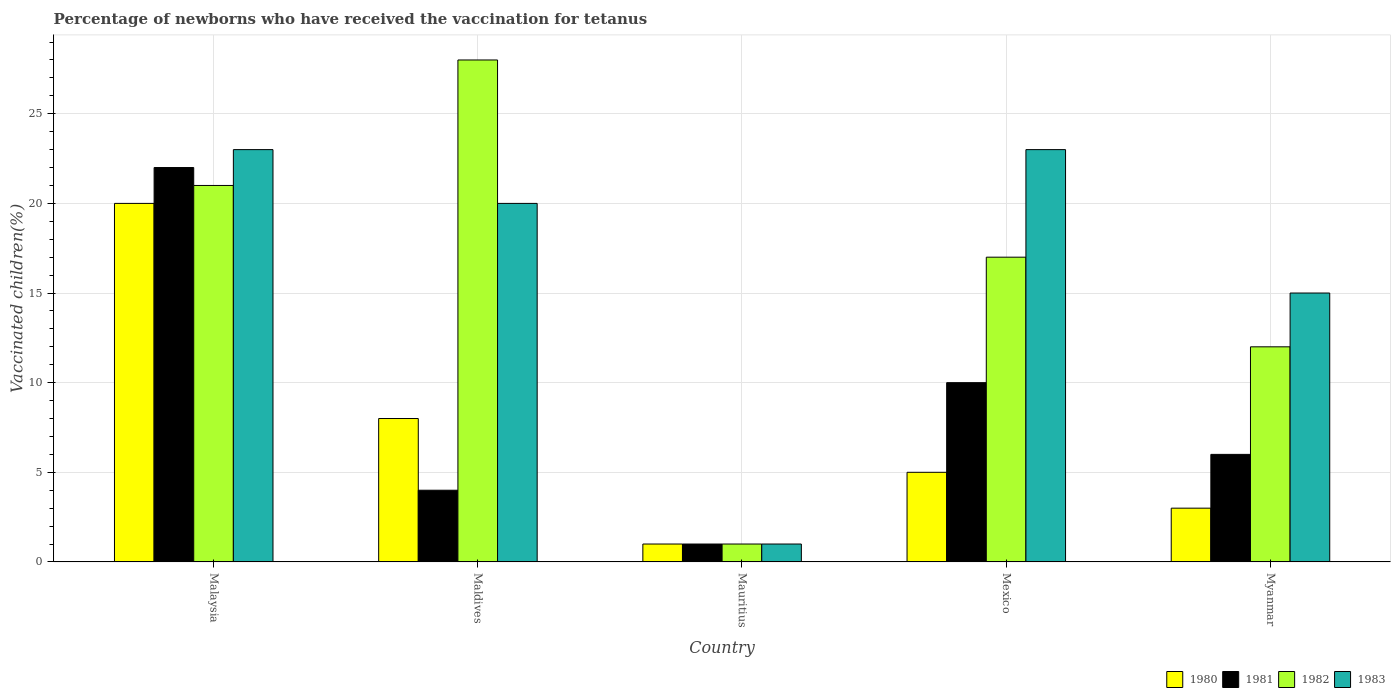How many groups of bars are there?
Your response must be concise. 5. Are the number of bars per tick equal to the number of legend labels?
Provide a succinct answer. Yes. Are the number of bars on each tick of the X-axis equal?
Give a very brief answer. Yes. In how many cases, is the number of bars for a given country not equal to the number of legend labels?
Your response must be concise. 0. What is the percentage of vaccinated children in 1983 in Malaysia?
Make the answer very short. 23. Across all countries, what is the maximum percentage of vaccinated children in 1982?
Make the answer very short. 28. Across all countries, what is the minimum percentage of vaccinated children in 1981?
Offer a terse response. 1. In which country was the percentage of vaccinated children in 1980 maximum?
Your answer should be compact. Malaysia. In which country was the percentage of vaccinated children in 1981 minimum?
Offer a very short reply. Mauritius. What is the ratio of the percentage of vaccinated children in 1981 in Maldives to that in Mexico?
Offer a very short reply. 0.4. Is the percentage of vaccinated children in 1980 in Malaysia less than that in Mauritius?
Ensure brevity in your answer.  No. What is the difference between the highest and the second highest percentage of vaccinated children in 1982?
Your response must be concise. -11. What does the 2nd bar from the left in Mexico represents?
Offer a terse response. 1981. What does the 2nd bar from the right in Malaysia represents?
Offer a very short reply. 1982. Is it the case that in every country, the sum of the percentage of vaccinated children in 1982 and percentage of vaccinated children in 1980 is greater than the percentage of vaccinated children in 1983?
Offer a very short reply. No. Does the graph contain any zero values?
Your answer should be compact. No. How are the legend labels stacked?
Provide a succinct answer. Horizontal. What is the title of the graph?
Give a very brief answer. Percentage of newborns who have received the vaccination for tetanus. What is the label or title of the Y-axis?
Your response must be concise. Vaccinated children(%). What is the Vaccinated children(%) of 1980 in Maldives?
Provide a short and direct response. 8. What is the Vaccinated children(%) in 1981 in Maldives?
Your answer should be very brief. 4. What is the Vaccinated children(%) in 1983 in Maldives?
Your response must be concise. 20. What is the Vaccinated children(%) in 1980 in Mauritius?
Offer a very short reply. 1. What is the Vaccinated children(%) of 1983 in Mauritius?
Your answer should be very brief. 1. What is the Vaccinated children(%) of 1981 in Mexico?
Your answer should be compact. 10. What is the Vaccinated children(%) in 1982 in Mexico?
Your response must be concise. 17. What is the Vaccinated children(%) in 1983 in Mexico?
Your response must be concise. 23. What is the Vaccinated children(%) of 1980 in Myanmar?
Make the answer very short. 3. What is the Vaccinated children(%) in 1981 in Myanmar?
Provide a short and direct response. 6. What is the Vaccinated children(%) in 1982 in Myanmar?
Keep it short and to the point. 12. Across all countries, what is the maximum Vaccinated children(%) of 1981?
Your answer should be compact. 22. Across all countries, what is the maximum Vaccinated children(%) of 1982?
Your response must be concise. 28. Across all countries, what is the minimum Vaccinated children(%) of 1983?
Your answer should be compact. 1. What is the total Vaccinated children(%) of 1982 in the graph?
Offer a terse response. 79. What is the difference between the Vaccinated children(%) of 1981 in Malaysia and that in Maldives?
Offer a very short reply. 18. What is the difference between the Vaccinated children(%) in 1982 in Malaysia and that in Maldives?
Your answer should be very brief. -7. What is the difference between the Vaccinated children(%) in 1983 in Malaysia and that in Maldives?
Your answer should be compact. 3. What is the difference between the Vaccinated children(%) of 1981 in Malaysia and that in Mauritius?
Keep it short and to the point. 21. What is the difference between the Vaccinated children(%) of 1982 in Malaysia and that in Mauritius?
Your answer should be compact. 20. What is the difference between the Vaccinated children(%) of 1980 in Malaysia and that in Mexico?
Keep it short and to the point. 15. What is the difference between the Vaccinated children(%) of 1982 in Malaysia and that in Mexico?
Make the answer very short. 4. What is the difference between the Vaccinated children(%) of 1983 in Malaysia and that in Mexico?
Offer a terse response. 0. What is the difference between the Vaccinated children(%) in 1980 in Malaysia and that in Myanmar?
Offer a very short reply. 17. What is the difference between the Vaccinated children(%) of 1980 in Maldives and that in Mauritius?
Keep it short and to the point. 7. What is the difference between the Vaccinated children(%) in 1981 in Maldives and that in Mauritius?
Provide a short and direct response. 3. What is the difference between the Vaccinated children(%) in 1983 in Maldives and that in Mauritius?
Ensure brevity in your answer.  19. What is the difference between the Vaccinated children(%) of 1980 in Maldives and that in Mexico?
Your answer should be very brief. 3. What is the difference between the Vaccinated children(%) of 1981 in Maldives and that in Mexico?
Offer a terse response. -6. What is the difference between the Vaccinated children(%) of 1982 in Maldives and that in Mexico?
Provide a succinct answer. 11. What is the difference between the Vaccinated children(%) in 1983 in Maldives and that in Mexico?
Provide a succinct answer. -3. What is the difference between the Vaccinated children(%) of 1982 in Maldives and that in Myanmar?
Your response must be concise. 16. What is the difference between the Vaccinated children(%) of 1982 in Mauritius and that in Mexico?
Make the answer very short. -16. What is the difference between the Vaccinated children(%) of 1983 in Mauritius and that in Myanmar?
Ensure brevity in your answer.  -14. What is the difference between the Vaccinated children(%) of 1980 in Mexico and that in Myanmar?
Ensure brevity in your answer.  2. What is the difference between the Vaccinated children(%) of 1982 in Mexico and that in Myanmar?
Your answer should be compact. 5. What is the difference between the Vaccinated children(%) in 1983 in Mexico and that in Myanmar?
Keep it short and to the point. 8. What is the difference between the Vaccinated children(%) in 1980 in Malaysia and the Vaccinated children(%) in 1982 in Maldives?
Offer a terse response. -8. What is the difference between the Vaccinated children(%) in 1982 in Malaysia and the Vaccinated children(%) in 1983 in Maldives?
Make the answer very short. 1. What is the difference between the Vaccinated children(%) in 1980 in Malaysia and the Vaccinated children(%) in 1981 in Mauritius?
Keep it short and to the point. 19. What is the difference between the Vaccinated children(%) in 1980 in Malaysia and the Vaccinated children(%) in 1983 in Mauritius?
Your answer should be very brief. 19. What is the difference between the Vaccinated children(%) in 1981 in Malaysia and the Vaccinated children(%) in 1982 in Mauritius?
Give a very brief answer. 21. What is the difference between the Vaccinated children(%) of 1981 in Malaysia and the Vaccinated children(%) of 1983 in Mauritius?
Ensure brevity in your answer.  21. What is the difference between the Vaccinated children(%) of 1980 in Malaysia and the Vaccinated children(%) of 1983 in Mexico?
Offer a very short reply. -3. What is the difference between the Vaccinated children(%) of 1981 in Malaysia and the Vaccinated children(%) of 1982 in Mexico?
Offer a very short reply. 5. What is the difference between the Vaccinated children(%) in 1982 in Malaysia and the Vaccinated children(%) in 1983 in Mexico?
Your response must be concise. -2. What is the difference between the Vaccinated children(%) in 1980 in Malaysia and the Vaccinated children(%) in 1981 in Myanmar?
Ensure brevity in your answer.  14. What is the difference between the Vaccinated children(%) of 1980 in Malaysia and the Vaccinated children(%) of 1982 in Myanmar?
Offer a very short reply. 8. What is the difference between the Vaccinated children(%) in 1981 in Malaysia and the Vaccinated children(%) in 1982 in Myanmar?
Offer a very short reply. 10. What is the difference between the Vaccinated children(%) of 1981 in Malaysia and the Vaccinated children(%) of 1983 in Myanmar?
Give a very brief answer. 7. What is the difference between the Vaccinated children(%) in 1982 in Malaysia and the Vaccinated children(%) in 1983 in Myanmar?
Offer a very short reply. 6. What is the difference between the Vaccinated children(%) of 1980 in Maldives and the Vaccinated children(%) of 1982 in Mauritius?
Make the answer very short. 7. What is the difference between the Vaccinated children(%) in 1981 in Maldives and the Vaccinated children(%) in 1982 in Mauritius?
Your answer should be compact. 3. What is the difference between the Vaccinated children(%) in 1980 in Maldives and the Vaccinated children(%) in 1981 in Mexico?
Keep it short and to the point. -2. What is the difference between the Vaccinated children(%) of 1980 in Maldives and the Vaccinated children(%) of 1983 in Mexico?
Your answer should be very brief. -15. What is the difference between the Vaccinated children(%) of 1981 in Maldives and the Vaccinated children(%) of 1982 in Mexico?
Offer a terse response. -13. What is the difference between the Vaccinated children(%) of 1982 in Maldives and the Vaccinated children(%) of 1983 in Mexico?
Provide a short and direct response. 5. What is the difference between the Vaccinated children(%) in 1980 in Maldives and the Vaccinated children(%) in 1981 in Myanmar?
Give a very brief answer. 2. What is the difference between the Vaccinated children(%) in 1980 in Maldives and the Vaccinated children(%) in 1983 in Myanmar?
Ensure brevity in your answer.  -7. What is the difference between the Vaccinated children(%) in 1982 in Maldives and the Vaccinated children(%) in 1983 in Myanmar?
Make the answer very short. 13. What is the difference between the Vaccinated children(%) in 1980 in Mauritius and the Vaccinated children(%) in 1981 in Mexico?
Your response must be concise. -9. What is the difference between the Vaccinated children(%) of 1980 in Mauritius and the Vaccinated children(%) of 1982 in Mexico?
Offer a terse response. -16. What is the difference between the Vaccinated children(%) in 1980 in Mauritius and the Vaccinated children(%) in 1983 in Mexico?
Ensure brevity in your answer.  -22. What is the difference between the Vaccinated children(%) of 1980 in Mauritius and the Vaccinated children(%) of 1983 in Myanmar?
Provide a succinct answer. -14. What is the difference between the Vaccinated children(%) in 1982 in Mauritius and the Vaccinated children(%) in 1983 in Myanmar?
Ensure brevity in your answer.  -14. What is the difference between the Vaccinated children(%) in 1980 in Mexico and the Vaccinated children(%) in 1981 in Myanmar?
Give a very brief answer. -1. What is the difference between the Vaccinated children(%) of 1980 in Mexico and the Vaccinated children(%) of 1983 in Myanmar?
Make the answer very short. -10. What is the difference between the Vaccinated children(%) in 1981 in Mexico and the Vaccinated children(%) in 1983 in Myanmar?
Offer a very short reply. -5. What is the average Vaccinated children(%) in 1981 per country?
Provide a succinct answer. 8.6. What is the average Vaccinated children(%) in 1982 per country?
Provide a succinct answer. 15.8. What is the average Vaccinated children(%) of 1983 per country?
Keep it short and to the point. 16.4. What is the difference between the Vaccinated children(%) in 1980 and Vaccinated children(%) in 1982 in Malaysia?
Your response must be concise. -1. What is the difference between the Vaccinated children(%) of 1980 and Vaccinated children(%) of 1983 in Malaysia?
Offer a terse response. -3. What is the difference between the Vaccinated children(%) in 1981 and Vaccinated children(%) in 1982 in Malaysia?
Your answer should be compact. 1. What is the difference between the Vaccinated children(%) in 1981 and Vaccinated children(%) in 1983 in Malaysia?
Provide a short and direct response. -1. What is the difference between the Vaccinated children(%) in 1980 and Vaccinated children(%) in 1981 in Maldives?
Your response must be concise. 4. What is the difference between the Vaccinated children(%) of 1980 and Vaccinated children(%) of 1982 in Maldives?
Ensure brevity in your answer.  -20. What is the difference between the Vaccinated children(%) of 1982 and Vaccinated children(%) of 1983 in Maldives?
Make the answer very short. 8. What is the difference between the Vaccinated children(%) in 1980 and Vaccinated children(%) in 1982 in Mauritius?
Provide a short and direct response. 0. What is the difference between the Vaccinated children(%) of 1981 and Vaccinated children(%) of 1982 in Mauritius?
Keep it short and to the point. 0. What is the difference between the Vaccinated children(%) of 1981 and Vaccinated children(%) of 1983 in Mauritius?
Your answer should be very brief. 0. What is the difference between the Vaccinated children(%) of 1982 and Vaccinated children(%) of 1983 in Mauritius?
Provide a short and direct response. 0. What is the difference between the Vaccinated children(%) of 1980 and Vaccinated children(%) of 1981 in Mexico?
Make the answer very short. -5. What is the difference between the Vaccinated children(%) in 1980 and Vaccinated children(%) in 1982 in Mexico?
Your response must be concise. -12. What is the difference between the Vaccinated children(%) of 1981 and Vaccinated children(%) of 1982 in Mexico?
Your response must be concise. -7. What is the difference between the Vaccinated children(%) in 1981 and Vaccinated children(%) in 1983 in Mexico?
Offer a terse response. -13. What is the difference between the Vaccinated children(%) in 1980 and Vaccinated children(%) in 1981 in Myanmar?
Offer a very short reply. -3. What is the difference between the Vaccinated children(%) of 1980 and Vaccinated children(%) of 1982 in Myanmar?
Provide a succinct answer. -9. What is the difference between the Vaccinated children(%) in 1981 and Vaccinated children(%) in 1982 in Myanmar?
Provide a succinct answer. -6. What is the difference between the Vaccinated children(%) of 1982 and Vaccinated children(%) of 1983 in Myanmar?
Offer a very short reply. -3. What is the ratio of the Vaccinated children(%) of 1981 in Malaysia to that in Maldives?
Offer a very short reply. 5.5. What is the ratio of the Vaccinated children(%) of 1982 in Malaysia to that in Maldives?
Your response must be concise. 0.75. What is the ratio of the Vaccinated children(%) of 1983 in Malaysia to that in Maldives?
Ensure brevity in your answer.  1.15. What is the ratio of the Vaccinated children(%) in 1980 in Malaysia to that in Mauritius?
Your response must be concise. 20. What is the ratio of the Vaccinated children(%) in 1981 in Malaysia to that in Mauritius?
Keep it short and to the point. 22. What is the ratio of the Vaccinated children(%) in 1983 in Malaysia to that in Mauritius?
Ensure brevity in your answer.  23. What is the ratio of the Vaccinated children(%) of 1982 in Malaysia to that in Mexico?
Give a very brief answer. 1.24. What is the ratio of the Vaccinated children(%) in 1983 in Malaysia to that in Mexico?
Offer a terse response. 1. What is the ratio of the Vaccinated children(%) of 1980 in Malaysia to that in Myanmar?
Your response must be concise. 6.67. What is the ratio of the Vaccinated children(%) in 1981 in Malaysia to that in Myanmar?
Your answer should be compact. 3.67. What is the ratio of the Vaccinated children(%) in 1982 in Malaysia to that in Myanmar?
Make the answer very short. 1.75. What is the ratio of the Vaccinated children(%) in 1983 in Malaysia to that in Myanmar?
Your answer should be compact. 1.53. What is the ratio of the Vaccinated children(%) in 1980 in Maldives to that in Mauritius?
Offer a terse response. 8. What is the ratio of the Vaccinated children(%) of 1981 in Maldives to that in Mauritius?
Offer a terse response. 4. What is the ratio of the Vaccinated children(%) in 1983 in Maldives to that in Mauritius?
Offer a terse response. 20. What is the ratio of the Vaccinated children(%) in 1981 in Maldives to that in Mexico?
Make the answer very short. 0.4. What is the ratio of the Vaccinated children(%) in 1982 in Maldives to that in Mexico?
Your response must be concise. 1.65. What is the ratio of the Vaccinated children(%) of 1983 in Maldives to that in Mexico?
Your answer should be very brief. 0.87. What is the ratio of the Vaccinated children(%) of 1980 in Maldives to that in Myanmar?
Provide a succinct answer. 2.67. What is the ratio of the Vaccinated children(%) of 1981 in Maldives to that in Myanmar?
Your response must be concise. 0.67. What is the ratio of the Vaccinated children(%) in 1982 in Maldives to that in Myanmar?
Make the answer very short. 2.33. What is the ratio of the Vaccinated children(%) of 1983 in Maldives to that in Myanmar?
Offer a very short reply. 1.33. What is the ratio of the Vaccinated children(%) in 1982 in Mauritius to that in Mexico?
Give a very brief answer. 0.06. What is the ratio of the Vaccinated children(%) of 1983 in Mauritius to that in Mexico?
Provide a succinct answer. 0.04. What is the ratio of the Vaccinated children(%) of 1981 in Mauritius to that in Myanmar?
Your answer should be compact. 0.17. What is the ratio of the Vaccinated children(%) in 1982 in Mauritius to that in Myanmar?
Ensure brevity in your answer.  0.08. What is the ratio of the Vaccinated children(%) in 1983 in Mauritius to that in Myanmar?
Make the answer very short. 0.07. What is the ratio of the Vaccinated children(%) in 1980 in Mexico to that in Myanmar?
Your response must be concise. 1.67. What is the ratio of the Vaccinated children(%) of 1982 in Mexico to that in Myanmar?
Your answer should be compact. 1.42. What is the ratio of the Vaccinated children(%) of 1983 in Mexico to that in Myanmar?
Offer a very short reply. 1.53. What is the difference between the highest and the second highest Vaccinated children(%) in 1983?
Offer a terse response. 0. 